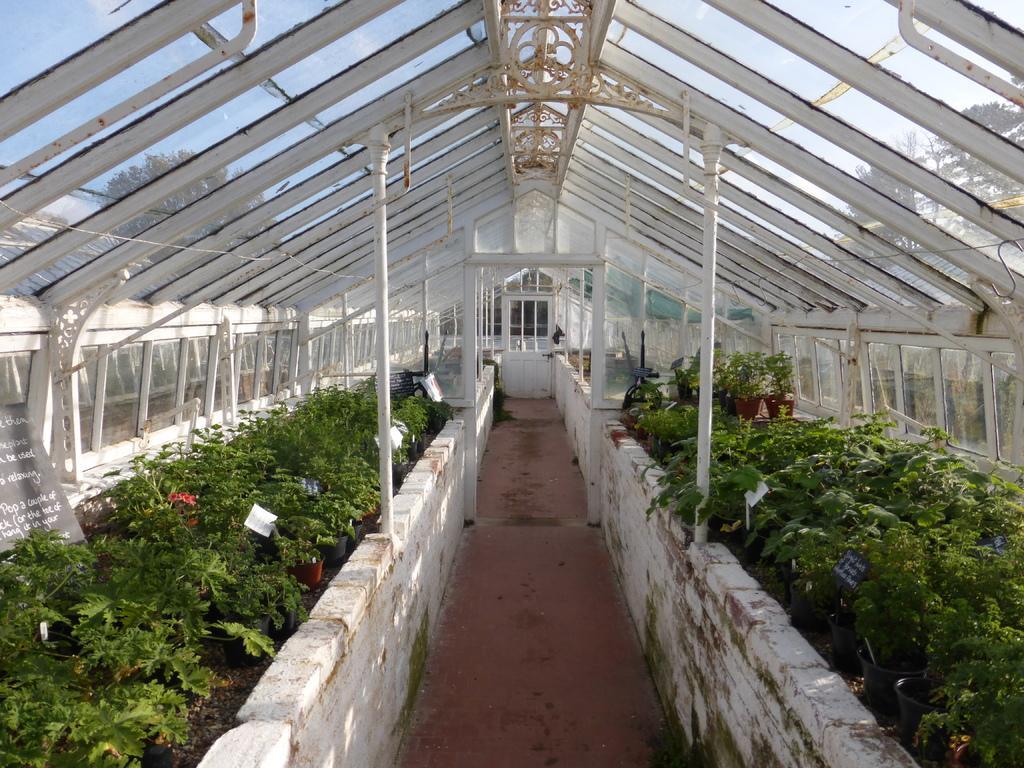How would you summarize this image in a sentence or two? In this image, I can see the plants and flower pots. These are the leaves. On the left side of the image, I can see the letters written on it. I think this is a glass shed. I can see the trees through the glass doors. This looks like a pathway. In the background, I can see a door. 